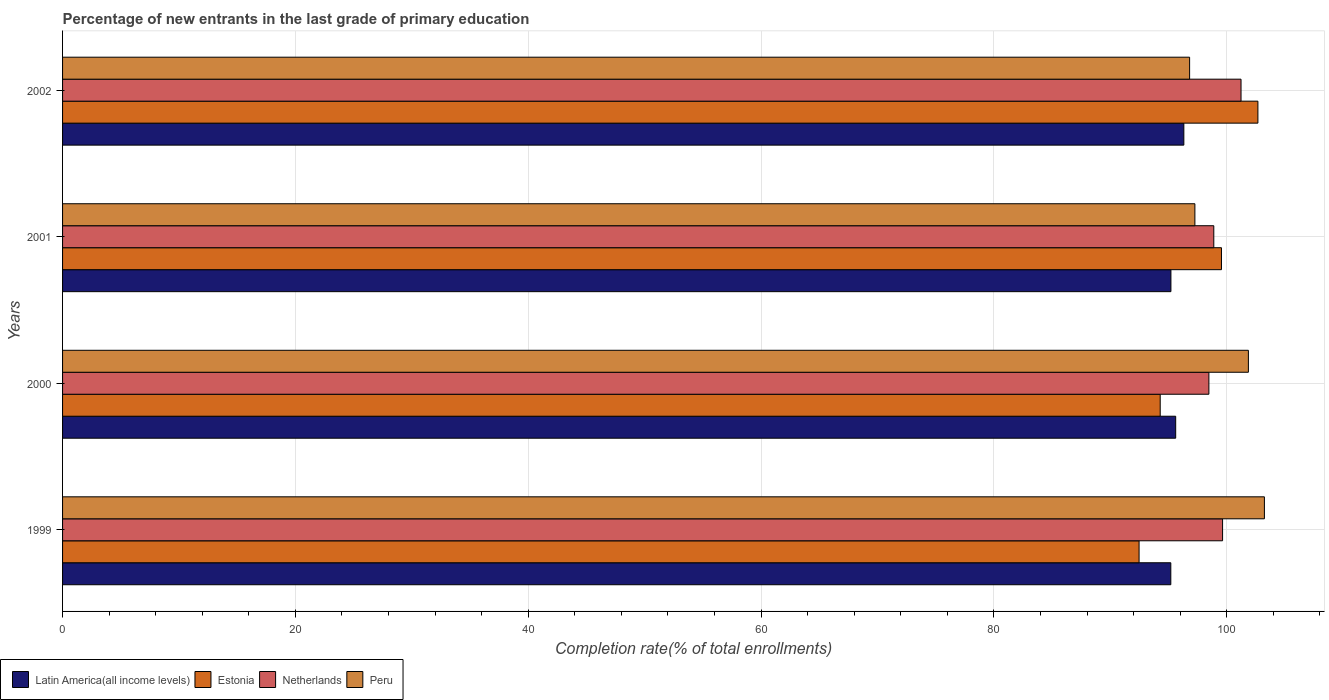How many different coloured bars are there?
Your answer should be compact. 4. How many groups of bars are there?
Provide a short and direct response. 4. Are the number of bars per tick equal to the number of legend labels?
Offer a terse response. Yes. How many bars are there on the 2nd tick from the top?
Give a very brief answer. 4. What is the label of the 1st group of bars from the top?
Your answer should be compact. 2002. In how many cases, is the number of bars for a given year not equal to the number of legend labels?
Give a very brief answer. 0. What is the percentage of new entrants in Latin America(all income levels) in 2000?
Ensure brevity in your answer.  95.61. Across all years, what is the maximum percentage of new entrants in Peru?
Provide a succinct answer. 103.23. Across all years, what is the minimum percentage of new entrants in Estonia?
Your answer should be very brief. 92.47. In which year was the percentage of new entrants in Estonia minimum?
Offer a very short reply. 1999. What is the total percentage of new entrants in Estonia in the graph?
Offer a terse response. 388.97. What is the difference between the percentage of new entrants in Peru in 2000 and that in 2001?
Your answer should be compact. 4.6. What is the difference between the percentage of new entrants in Netherlands in 2000 and the percentage of new entrants in Latin America(all income levels) in 2001?
Give a very brief answer. 3.26. What is the average percentage of new entrants in Estonia per year?
Make the answer very short. 97.24. In the year 1999, what is the difference between the percentage of new entrants in Estonia and percentage of new entrants in Peru?
Provide a short and direct response. -10.76. In how many years, is the percentage of new entrants in Netherlands greater than 32 %?
Offer a terse response. 4. What is the ratio of the percentage of new entrants in Peru in 2001 to that in 2002?
Provide a succinct answer. 1. Is the percentage of new entrants in Latin America(all income levels) in 2000 less than that in 2002?
Provide a short and direct response. Yes. Is the difference between the percentage of new entrants in Estonia in 1999 and 2002 greater than the difference between the percentage of new entrants in Peru in 1999 and 2002?
Ensure brevity in your answer.  No. What is the difference between the highest and the second highest percentage of new entrants in Latin America(all income levels)?
Offer a terse response. 0.7. What is the difference between the highest and the lowest percentage of new entrants in Netherlands?
Your response must be concise. 2.76. What does the 2nd bar from the bottom in 2002 represents?
Your answer should be very brief. Estonia. How many bars are there?
Make the answer very short. 16. How many years are there in the graph?
Your answer should be compact. 4. Does the graph contain any zero values?
Your response must be concise. No. Where does the legend appear in the graph?
Keep it short and to the point. Bottom left. How many legend labels are there?
Offer a very short reply. 4. What is the title of the graph?
Provide a succinct answer. Percentage of new entrants in the last grade of primary education. What is the label or title of the X-axis?
Your response must be concise. Completion rate(% of total enrollments). What is the label or title of the Y-axis?
Make the answer very short. Years. What is the Completion rate(% of total enrollments) in Latin America(all income levels) in 1999?
Keep it short and to the point. 95.19. What is the Completion rate(% of total enrollments) of Estonia in 1999?
Make the answer very short. 92.47. What is the Completion rate(% of total enrollments) in Netherlands in 1999?
Offer a terse response. 99.64. What is the Completion rate(% of total enrollments) in Peru in 1999?
Offer a very short reply. 103.23. What is the Completion rate(% of total enrollments) of Latin America(all income levels) in 2000?
Ensure brevity in your answer.  95.61. What is the Completion rate(% of total enrollments) of Estonia in 2000?
Your response must be concise. 94.28. What is the Completion rate(% of total enrollments) in Netherlands in 2000?
Your response must be concise. 98.46. What is the Completion rate(% of total enrollments) in Peru in 2000?
Your response must be concise. 101.86. What is the Completion rate(% of total enrollments) of Latin America(all income levels) in 2001?
Your response must be concise. 95.2. What is the Completion rate(% of total enrollments) in Estonia in 2001?
Offer a terse response. 99.54. What is the Completion rate(% of total enrollments) in Netherlands in 2001?
Provide a succinct answer. 98.89. What is the Completion rate(% of total enrollments) in Peru in 2001?
Ensure brevity in your answer.  97.26. What is the Completion rate(% of total enrollments) in Latin America(all income levels) in 2002?
Your response must be concise. 96.31. What is the Completion rate(% of total enrollments) in Estonia in 2002?
Make the answer very short. 102.67. What is the Completion rate(% of total enrollments) in Netherlands in 2002?
Provide a succinct answer. 101.22. What is the Completion rate(% of total enrollments) of Peru in 2002?
Your response must be concise. 96.81. Across all years, what is the maximum Completion rate(% of total enrollments) of Latin America(all income levels)?
Provide a succinct answer. 96.31. Across all years, what is the maximum Completion rate(% of total enrollments) in Estonia?
Offer a terse response. 102.67. Across all years, what is the maximum Completion rate(% of total enrollments) of Netherlands?
Make the answer very short. 101.22. Across all years, what is the maximum Completion rate(% of total enrollments) of Peru?
Your answer should be compact. 103.23. Across all years, what is the minimum Completion rate(% of total enrollments) of Latin America(all income levels)?
Provide a succinct answer. 95.19. Across all years, what is the minimum Completion rate(% of total enrollments) in Estonia?
Provide a succinct answer. 92.47. Across all years, what is the minimum Completion rate(% of total enrollments) in Netherlands?
Ensure brevity in your answer.  98.46. Across all years, what is the minimum Completion rate(% of total enrollments) in Peru?
Ensure brevity in your answer.  96.81. What is the total Completion rate(% of total enrollments) of Latin America(all income levels) in the graph?
Offer a terse response. 382.32. What is the total Completion rate(% of total enrollments) in Estonia in the graph?
Keep it short and to the point. 388.97. What is the total Completion rate(% of total enrollments) in Netherlands in the graph?
Make the answer very short. 398.21. What is the total Completion rate(% of total enrollments) in Peru in the graph?
Ensure brevity in your answer.  399.16. What is the difference between the Completion rate(% of total enrollments) of Latin America(all income levels) in 1999 and that in 2000?
Your answer should be compact. -0.42. What is the difference between the Completion rate(% of total enrollments) of Estonia in 1999 and that in 2000?
Provide a short and direct response. -1.81. What is the difference between the Completion rate(% of total enrollments) of Netherlands in 1999 and that in 2000?
Offer a terse response. 1.18. What is the difference between the Completion rate(% of total enrollments) in Peru in 1999 and that in 2000?
Your answer should be very brief. 1.38. What is the difference between the Completion rate(% of total enrollments) in Latin America(all income levels) in 1999 and that in 2001?
Your answer should be very brief. -0.01. What is the difference between the Completion rate(% of total enrollments) of Estonia in 1999 and that in 2001?
Provide a succinct answer. -7.08. What is the difference between the Completion rate(% of total enrollments) of Netherlands in 1999 and that in 2001?
Provide a succinct answer. 0.75. What is the difference between the Completion rate(% of total enrollments) of Peru in 1999 and that in 2001?
Your answer should be compact. 5.97. What is the difference between the Completion rate(% of total enrollments) of Latin America(all income levels) in 1999 and that in 2002?
Ensure brevity in your answer.  -1.12. What is the difference between the Completion rate(% of total enrollments) in Estonia in 1999 and that in 2002?
Ensure brevity in your answer.  -10.21. What is the difference between the Completion rate(% of total enrollments) in Netherlands in 1999 and that in 2002?
Give a very brief answer. -1.58. What is the difference between the Completion rate(% of total enrollments) of Peru in 1999 and that in 2002?
Offer a terse response. 6.42. What is the difference between the Completion rate(% of total enrollments) of Latin America(all income levels) in 2000 and that in 2001?
Keep it short and to the point. 0.41. What is the difference between the Completion rate(% of total enrollments) of Estonia in 2000 and that in 2001?
Provide a succinct answer. -5.26. What is the difference between the Completion rate(% of total enrollments) in Netherlands in 2000 and that in 2001?
Provide a succinct answer. -0.42. What is the difference between the Completion rate(% of total enrollments) in Peru in 2000 and that in 2001?
Offer a very short reply. 4.6. What is the difference between the Completion rate(% of total enrollments) of Latin America(all income levels) in 2000 and that in 2002?
Your answer should be very brief. -0.7. What is the difference between the Completion rate(% of total enrollments) in Estonia in 2000 and that in 2002?
Provide a succinct answer. -8.39. What is the difference between the Completion rate(% of total enrollments) of Netherlands in 2000 and that in 2002?
Make the answer very short. -2.76. What is the difference between the Completion rate(% of total enrollments) of Peru in 2000 and that in 2002?
Provide a succinct answer. 5.05. What is the difference between the Completion rate(% of total enrollments) in Latin America(all income levels) in 2001 and that in 2002?
Your answer should be very brief. -1.11. What is the difference between the Completion rate(% of total enrollments) in Estonia in 2001 and that in 2002?
Provide a succinct answer. -3.13. What is the difference between the Completion rate(% of total enrollments) of Netherlands in 2001 and that in 2002?
Your answer should be compact. -2.34. What is the difference between the Completion rate(% of total enrollments) in Peru in 2001 and that in 2002?
Ensure brevity in your answer.  0.45. What is the difference between the Completion rate(% of total enrollments) of Latin America(all income levels) in 1999 and the Completion rate(% of total enrollments) of Estonia in 2000?
Your answer should be very brief. 0.91. What is the difference between the Completion rate(% of total enrollments) of Latin America(all income levels) in 1999 and the Completion rate(% of total enrollments) of Netherlands in 2000?
Make the answer very short. -3.27. What is the difference between the Completion rate(% of total enrollments) in Latin America(all income levels) in 1999 and the Completion rate(% of total enrollments) in Peru in 2000?
Your answer should be compact. -6.66. What is the difference between the Completion rate(% of total enrollments) of Estonia in 1999 and the Completion rate(% of total enrollments) of Netherlands in 2000?
Provide a succinct answer. -6. What is the difference between the Completion rate(% of total enrollments) in Estonia in 1999 and the Completion rate(% of total enrollments) in Peru in 2000?
Your answer should be very brief. -9.39. What is the difference between the Completion rate(% of total enrollments) in Netherlands in 1999 and the Completion rate(% of total enrollments) in Peru in 2000?
Provide a succinct answer. -2.22. What is the difference between the Completion rate(% of total enrollments) in Latin America(all income levels) in 1999 and the Completion rate(% of total enrollments) in Estonia in 2001?
Make the answer very short. -4.35. What is the difference between the Completion rate(% of total enrollments) of Latin America(all income levels) in 1999 and the Completion rate(% of total enrollments) of Netherlands in 2001?
Keep it short and to the point. -3.69. What is the difference between the Completion rate(% of total enrollments) of Latin America(all income levels) in 1999 and the Completion rate(% of total enrollments) of Peru in 2001?
Give a very brief answer. -2.07. What is the difference between the Completion rate(% of total enrollments) in Estonia in 1999 and the Completion rate(% of total enrollments) in Netherlands in 2001?
Ensure brevity in your answer.  -6.42. What is the difference between the Completion rate(% of total enrollments) in Estonia in 1999 and the Completion rate(% of total enrollments) in Peru in 2001?
Offer a terse response. -4.79. What is the difference between the Completion rate(% of total enrollments) of Netherlands in 1999 and the Completion rate(% of total enrollments) of Peru in 2001?
Your answer should be compact. 2.38. What is the difference between the Completion rate(% of total enrollments) in Latin America(all income levels) in 1999 and the Completion rate(% of total enrollments) in Estonia in 2002?
Give a very brief answer. -7.48. What is the difference between the Completion rate(% of total enrollments) of Latin America(all income levels) in 1999 and the Completion rate(% of total enrollments) of Netherlands in 2002?
Your response must be concise. -6.03. What is the difference between the Completion rate(% of total enrollments) in Latin America(all income levels) in 1999 and the Completion rate(% of total enrollments) in Peru in 2002?
Keep it short and to the point. -1.62. What is the difference between the Completion rate(% of total enrollments) of Estonia in 1999 and the Completion rate(% of total enrollments) of Netherlands in 2002?
Your answer should be compact. -8.76. What is the difference between the Completion rate(% of total enrollments) of Estonia in 1999 and the Completion rate(% of total enrollments) of Peru in 2002?
Provide a succinct answer. -4.34. What is the difference between the Completion rate(% of total enrollments) in Netherlands in 1999 and the Completion rate(% of total enrollments) in Peru in 2002?
Make the answer very short. 2.83. What is the difference between the Completion rate(% of total enrollments) of Latin America(all income levels) in 2000 and the Completion rate(% of total enrollments) of Estonia in 2001?
Your answer should be compact. -3.93. What is the difference between the Completion rate(% of total enrollments) in Latin America(all income levels) in 2000 and the Completion rate(% of total enrollments) in Netherlands in 2001?
Make the answer very short. -3.27. What is the difference between the Completion rate(% of total enrollments) in Latin America(all income levels) in 2000 and the Completion rate(% of total enrollments) in Peru in 2001?
Your answer should be compact. -1.65. What is the difference between the Completion rate(% of total enrollments) in Estonia in 2000 and the Completion rate(% of total enrollments) in Netherlands in 2001?
Give a very brief answer. -4.6. What is the difference between the Completion rate(% of total enrollments) in Estonia in 2000 and the Completion rate(% of total enrollments) in Peru in 2001?
Offer a very short reply. -2.98. What is the difference between the Completion rate(% of total enrollments) of Netherlands in 2000 and the Completion rate(% of total enrollments) of Peru in 2001?
Keep it short and to the point. 1.2. What is the difference between the Completion rate(% of total enrollments) of Latin America(all income levels) in 2000 and the Completion rate(% of total enrollments) of Estonia in 2002?
Your answer should be compact. -7.06. What is the difference between the Completion rate(% of total enrollments) in Latin America(all income levels) in 2000 and the Completion rate(% of total enrollments) in Netherlands in 2002?
Provide a short and direct response. -5.61. What is the difference between the Completion rate(% of total enrollments) of Latin America(all income levels) in 2000 and the Completion rate(% of total enrollments) of Peru in 2002?
Your answer should be very brief. -1.2. What is the difference between the Completion rate(% of total enrollments) in Estonia in 2000 and the Completion rate(% of total enrollments) in Netherlands in 2002?
Ensure brevity in your answer.  -6.94. What is the difference between the Completion rate(% of total enrollments) of Estonia in 2000 and the Completion rate(% of total enrollments) of Peru in 2002?
Your response must be concise. -2.53. What is the difference between the Completion rate(% of total enrollments) in Netherlands in 2000 and the Completion rate(% of total enrollments) in Peru in 2002?
Make the answer very short. 1.66. What is the difference between the Completion rate(% of total enrollments) of Latin America(all income levels) in 2001 and the Completion rate(% of total enrollments) of Estonia in 2002?
Your answer should be compact. -7.47. What is the difference between the Completion rate(% of total enrollments) of Latin America(all income levels) in 2001 and the Completion rate(% of total enrollments) of Netherlands in 2002?
Keep it short and to the point. -6.02. What is the difference between the Completion rate(% of total enrollments) of Latin America(all income levels) in 2001 and the Completion rate(% of total enrollments) of Peru in 2002?
Provide a succinct answer. -1.61. What is the difference between the Completion rate(% of total enrollments) of Estonia in 2001 and the Completion rate(% of total enrollments) of Netherlands in 2002?
Keep it short and to the point. -1.68. What is the difference between the Completion rate(% of total enrollments) of Estonia in 2001 and the Completion rate(% of total enrollments) of Peru in 2002?
Keep it short and to the point. 2.74. What is the difference between the Completion rate(% of total enrollments) of Netherlands in 2001 and the Completion rate(% of total enrollments) of Peru in 2002?
Ensure brevity in your answer.  2.08. What is the average Completion rate(% of total enrollments) of Latin America(all income levels) per year?
Provide a short and direct response. 95.58. What is the average Completion rate(% of total enrollments) of Estonia per year?
Offer a very short reply. 97.24. What is the average Completion rate(% of total enrollments) in Netherlands per year?
Ensure brevity in your answer.  99.55. What is the average Completion rate(% of total enrollments) of Peru per year?
Offer a very short reply. 99.79. In the year 1999, what is the difference between the Completion rate(% of total enrollments) in Latin America(all income levels) and Completion rate(% of total enrollments) in Estonia?
Keep it short and to the point. 2.72. In the year 1999, what is the difference between the Completion rate(% of total enrollments) in Latin America(all income levels) and Completion rate(% of total enrollments) in Netherlands?
Your response must be concise. -4.45. In the year 1999, what is the difference between the Completion rate(% of total enrollments) of Latin America(all income levels) and Completion rate(% of total enrollments) of Peru?
Keep it short and to the point. -8.04. In the year 1999, what is the difference between the Completion rate(% of total enrollments) in Estonia and Completion rate(% of total enrollments) in Netherlands?
Provide a short and direct response. -7.17. In the year 1999, what is the difference between the Completion rate(% of total enrollments) of Estonia and Completion rate(% of total enrollments) of Peru?
Offer a very short reply. -10.76. In the year 1999, what is the difference between the Completion rate(% of total enrollments) in Netherlands and Completion rate(% of total enrollments) in Peru?
Keep it short and to the point. -3.59. In the year 2000, what is the difference between the Completion rate(% of total enrollments) of Latin America(all income levels) and Completion rate(% of total enrollments) of Estonia?
Offer a terse response. 1.33. In the year 2000, what is the difference between the Completion rate(% of total enrollments) of Latin America(all income levels) and Completion rate(% of total enrollments) of Netherlands?
Your response must be concise. -2.85. In the year 2000, what is the difference between the Completion rate(% of total enrollments) of Latin America(all income levels) and Completion rate(% of total enrollments) of Peru?
Your answer should be very brief. -6.25. In the year 2000, what is the difference between the Completion rate(% of total enrollments) of Estonia and Completion rate(% of total enrollments) of Netherlands?
Provide a short and direct response. -4.18. In the year 2000, what is the difference between the Completion rate(% of total enrollments) in Estonia and Completion rate(% of total enrollments) in Peru?
Ensure brevity in your answer.  -7.57. In the year 2000, what is the difference between the Completion rate(% of total enrollments) of Netherlands and Completion rate(% of total enrollments) of Peru?
Your answer should be compact. -3.39. In the year 2001, what is the difference between the Completion rate(% of total enrollments) in Latin America(all income levels) and Completion rate(% of total enrollments) in Estonia?
Provide a succinct answer. -4.34. In the year 2001, what is the difference between the Completion rate(% of total enrollments) in Latin America(all income levels) and Completion rate(% of total enrollments) in Netherlands?
Ensure brevity in your answer.  -3.68. In the year 2001, what is the difference between the Completion rate(% of total enrollments) in Latin America(all income levels) and Completion rate(% of total enrollments) in Peru?
Offer a very short reply. -2.06. In the year 2001, what is the difference between the Completion rate(% of total enrollments) of Estonia and Completion rate(% of total enrollments) of Netherlands?
Make the answer very short. 0.66. In the year 2001, what is the difference between the Completion rate(% of total enrollments) in Estonia and Completion rate(% of total enrollments) in Peru?
Give a very brief answer. 2.28. In the year 2001, what is the difference between the Completion rate(% of total enrollments) of Netherlands and Completion rate(% of total enrollments) of Peru?
Give a very brief answer. 1.62. In the year 2002, what is the difference between the Completion rate(% of total enrollments) in Latin America(all income levels) and Completion rate(% of total enrollments) in Estonia?
Ensure brevity in your answer.  -6.36. In the year 2002, what is the difference between the Completion rate(% of total enrollments) in Latin America(all income levels) and Completion rate(% of total enrollments) in Netherlands?
Make the answer very short. -4.91. In the year 2002, what is the difference between the Completion rate(% of total enrollments) in Latin America(all income levels) and Completion rate(% of total enrollments) in Peru?
Provide a short and direct response. -0.5. In the year 2002, what is the difference between the Completion rate(% of total enrollments) in Estonia and Completion rate(% of total enrollments) in Netherlands?
Keep it short and to the point. 1.45. In the year 2002, what is the difference between the Completion rate(% of total enrollments) of Estonia and Completion rate(% of total enrollments) of Peru?
Provide a short and direct response. 5.87. In the year 2002, what is the difference between the Completion rate(% of total enrollments) of Netherlands and Completion rate(% of total enrollments) of Peru?
Make the answer very short. 4.42. What is the ratio of the Completion rate(% of total enrollments) in Estonia in 1999 to that in 2000?
Provide a short and direct response. 0.98. What is the ratio of the Completion rate(% of total enrollments) in Netherlands in 1999 to that in 2000?
Offer a terse response. 1.01. What is the ratio of the Completion rate(% of total enrollments) of Peru in 1999 to that in 2000?
Keep it short and to the point. 1.01. What is the ratio of the Completion rate(% of total enrollments) of Latin America(all income levels) in 1999 to that in 2001?
Offer a terse response. 1. What is the ratio of the Completion rate(% of total enrollments) of Estonia in 1999 to that in 2001?
Offer a very short reply. 0.93. What is the ratio of the Completion rate(% of total enrollments) of Netherlands in 1999 to that in 2001?
Offer a terse response. 1.01. What is the ratio of the Completion rate(% of total enrollments) in Peru in 1999 to that in 2001?
Keep it short and to the point. 1.06. What is the ratio of the Completion rate(% of total enrollments) of Latin America(all income levels) in 1999 to that in 2002?
Ensure brevity in your answer.  0.99. What is the ratio of the Completion rate(% of total enrollments) of Estonia in 1999 to that in 2002?
Provide a short and direct response. 0.9. What is the ratio of the Completion rate(% of total enrollments) of Netherlands in 1999 to that in 2002?
Ensure brevity in your answer.  0.98. What is the ratio of the Completion rate(% of total enrollments) in Peru in 1999 to that in 2002?
Offer a terse response. 1.07. What is the ratio of the Completion rate(% of total enrollments) in Estonia in 2000 to that in 2001?
Your answer should be very brief. 0.95. What is the ratio of the Completion rate(% of total enrollments) of Peru in 2000 to that in 2001?
Your response must be concise. 1.05. What is the ratio of the Completion rate(% of total enrollments) of Estonia in 2000 to that in 2002?
Offer a very short reply. 0.92. What is the ratio of the Completion rate(% of total enrollments) in Netherlands in 2000 to that in 2002?
Provide a short and direct response. 0.97. What is the ratio of the Completion rate(% of total enrollments) of Peru in 2000 to that in 2002?
Provide a succinct answer. 1.05. What is the ratio of the Completion rate(% of total enrollments) in Estonia in 2001 to that in 2002?
Provide a succinct answer. 0.97. What is the ratio of the Completion rate(% of total enrollments) in Netherlands in 2001 to that in 2002?
Provide a succinct answer. 0.98. What is the ratio of the Completion rate(% of total enrollments) of Peru in 2001 to that in 2002?
Provide a short and direct response. 1. What is the difference between the highest and the second highest Completion rate(% of total enrollments) of Latin America(all income levels)?
Your answer should be compact. 0.7. What is the difference between the highest and the second highest Completion rate(% of total enrollments) of Estonia?
Give a very brief answer. 3.13. What is the difference between the highest and the second highest Completion rate(% of total enrollments) in Netherlands?
Provide a succinct answer. 1.58. What is the difference between the highest and the second highest Completion rate(% of total enrollments) of Peru?
Offer a very short reply. 1.38. What is the difference between the highest and the lowest Completion rate(% of total enrollments) in Latin America(all income levels)?
Ensure brevity in your answer.  1.12. What is the difference between the highest and the lowest Completion rate(% of total enrollments) in Estonia?
Ensure brevity in your answer.  10.21. What is the difference between the highest and the lowest Completion rate(% of total enrollments) of Netherlands?
Provide a succinct answer. 2.76. What is the difference between the highest and the lowest Completion rate(% of total enrollments) of Peru?
Provide a short and direct response. 6.42. 